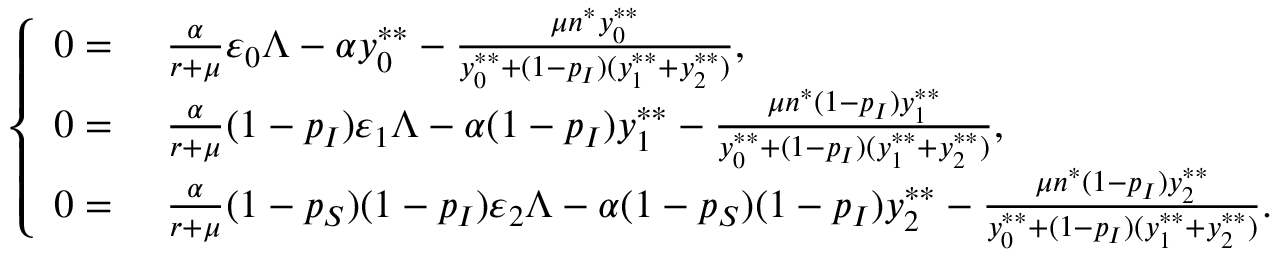Convert formula to latex. <formula><loc_0><loc_0><loc_500><loc_500>\left \{ \begin{array} { r l } { 0 = } & { \frac { \alpha } { r + \mu } \varepsilon _ { 0 } \Lambda - \alpha y _ { 0 } ^ { * * } - \frac { \mu n ^ { * } y _ { 0 } ^ { * * } } { y _ { 0 } ^ { * * } + ( 1 - p _ { I } ) ( y _ { 1 } ^ { * * } + y _ { 2 } ^ { * * } ) } , } \\ { 0 = } & { \frac { \alpha } { r + \mu } ( 1 - p _ { I } ) \varepsilon _ { 1 } \Lambda - \alpha ( 1 - p _ { I } ) y _ { 1 } ^ { * * } - \frac { \mu n ^ { * } ( 1 - p _ { I } ) y _ { 1 } ^ { * * } } { y _ { 0 } ^ { * * } + ( 1 - p _ { I } ) ( y _ { 1 } ^ { * * } + y _ { 2 } ^ { * * } ) } , } \\ { 0 = } & { \frac { \alpha } { r + \mu } ( 1 - p _ { S } ) ( 1 - p _ { I } ) \varepsilon _ { 2 } \Lambda - \alpha ( 1 - p _ { S } ) ( 1 - p _ { I } ) y _ { 2 } ^ { * * } - \frac { \mu n ^ { * } ( 1 - p _ { I } ) y _ { 2 } ^ { * * } } { y _ { 0 } ^ { * * } + ( 1 - p _ { I } ) ( y _ { 1 } ^ { * * } + y _ { 2 } ^ { * * } ) } . } \end{array}</formula> 